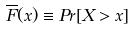Convert formula to latex. <formula><loc_0><loc_0><loc_500><loc_500>\overline { F } ( x ) \equiv P r [ X > x ]</formula> 